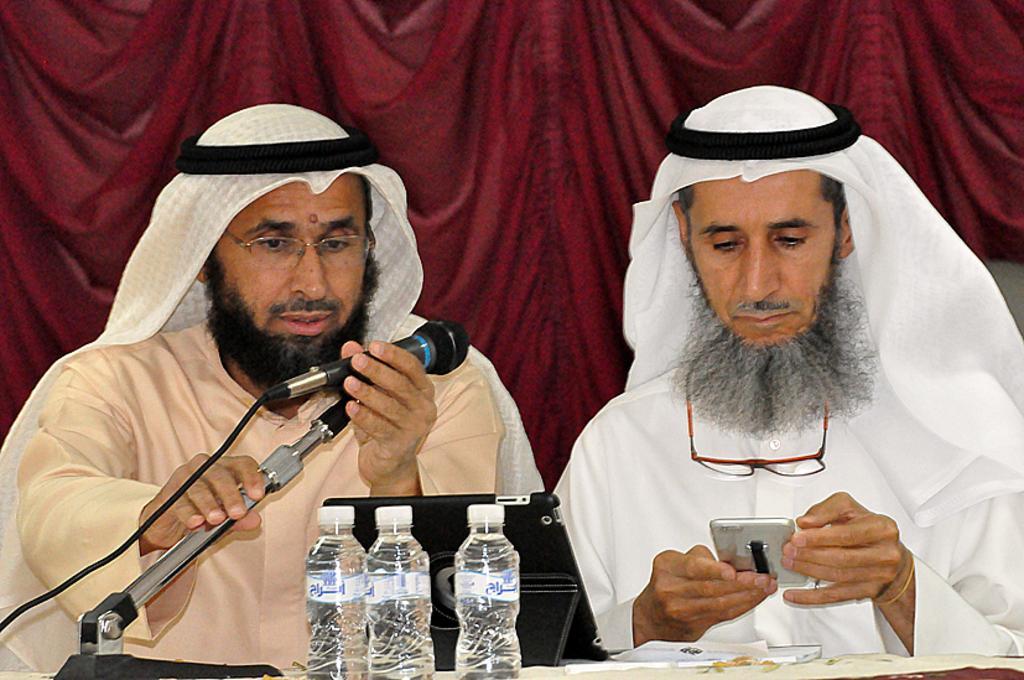Can you describe this image briefly? Man on the right corner of the picture wearing white dress is holding mobile phone in his hand. Beside him, man in cream shirt is holding microphone in his hand and both of them are sitting on chair in front of table on which we see papers, laptop and water bottles. Behind them, we see a sheet which is red in color. 